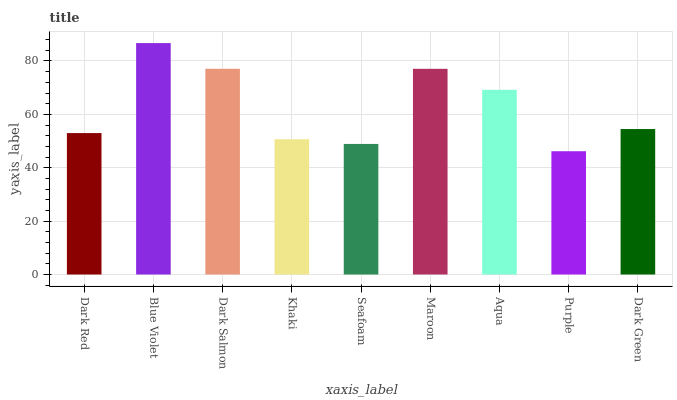Is Purple the minimum?
Answer yes or no. Yes. Is Blue Violet the maximum?
Answer yes or no. Yes. Is Dark Salmon the minimum?
Answer yes or no. No. Is Dark Salmon the maximum?
Answer yes or no. No. Is Blue Violet greater than Dark Salmon?
Answer yes or no. Yes. Is Dark Salmon less than Blue Violet?
Answer yes or no. Yes. Is Dark Salmon greater than Blue Violet?
Answer yes or no. No. Is Blue Violet less than Dark Salmon?
Answer yes or no. No. Is Dark Green the high median?
Answer yes or no. Yes. Is Dark Green the low median?
Answer yes or no. Yes. Is Khaki the high median?
Answer yes or no. No. Is Seafoam the low median?
Answer yes or no. No. 